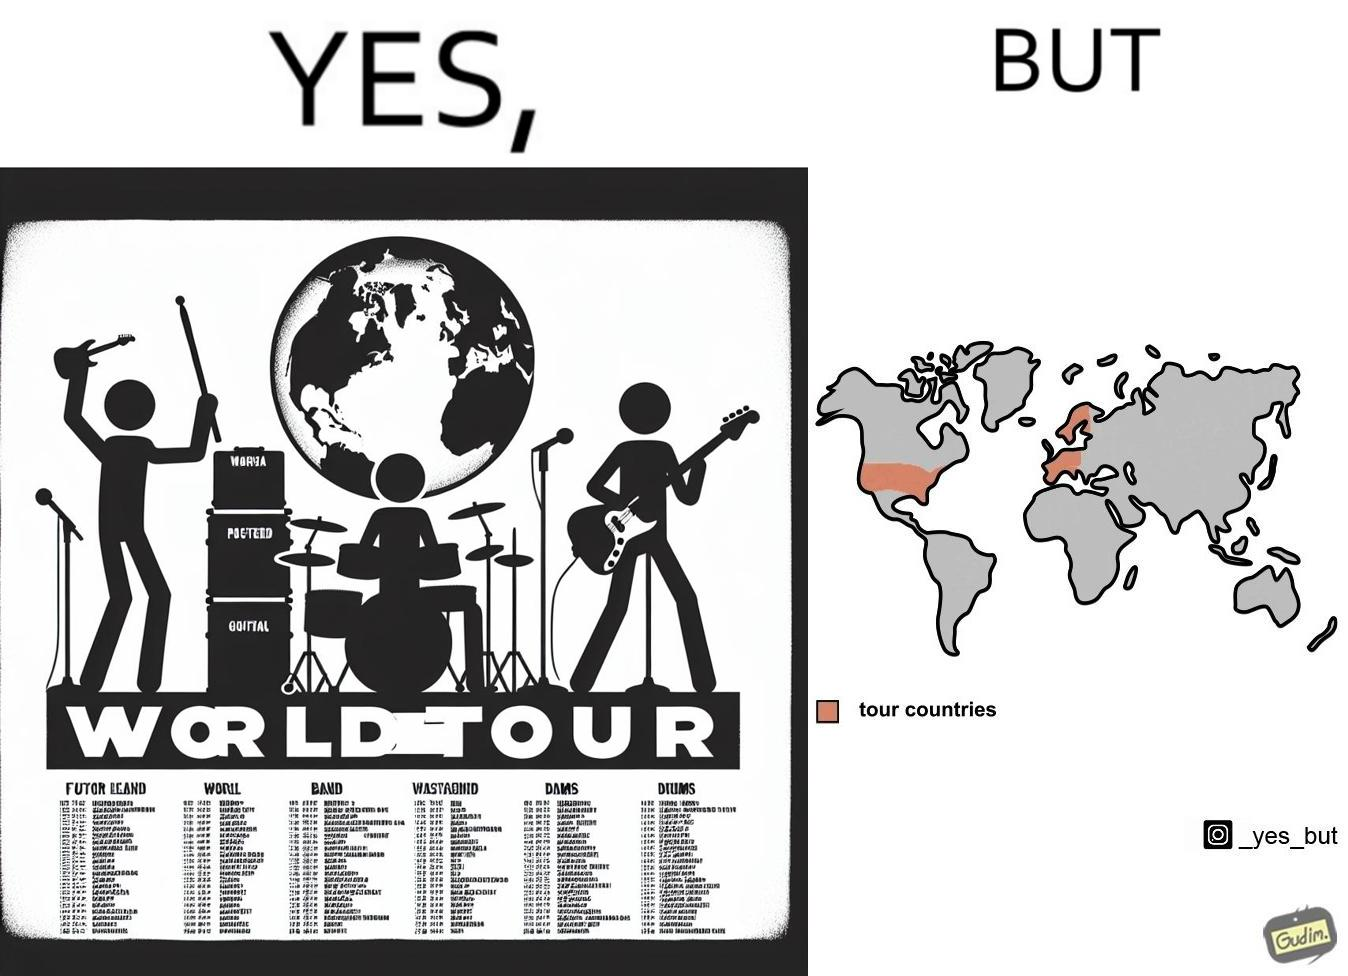What is shown in this image? The image is ironic, because in the first image some musical band is showing its poster of world tour but in the right image only a few countries are highlighted as tour countries 